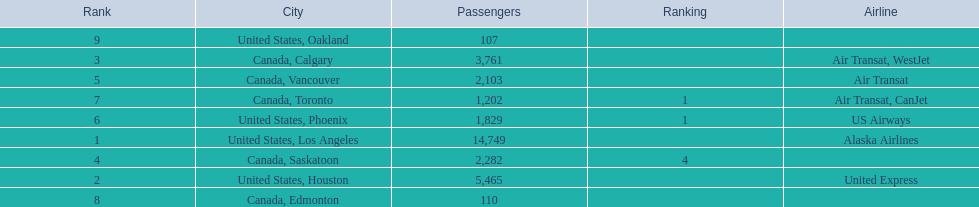What are all the cities? United States, Los Angeles, United States, Houston, Canada, Calgary, Canada, Saskatoon, Canada, Vancouver, United States, Phoenix, Canada, Toronto, Canada, Edmonton, United States, Oakland. How many passengers do they service? 14,749, 5,465, 3,761, 2,282, 2,103, 1,829, 1,202, 110, 107. Which city, when combined with los angeles, totals nearly 19,000? Canada, Calgary. Can you give me this table as a dict? {'header': ['Rank', 'City', 'Passengers', 'Ranking', 'Airline'], 'rows': [['9', 'United States, Oakland', '107', '', ''], ['3', 'Canada, Calgary', '3,761', '', 'Air Transat, WestJet'], ['5', 'Canada, Vancouver', '2,103', '', 'Air Transat'], ['7', 'Canada, Toronto', '1,202', '1', 'Air Transat, CanJet'], ['6', 'United States, Phoenix', '1,829', '1', 'US Airways'], ['1', 'United States, Los Angeles', '14,749', '', 'Alaska Airlines'], ['4', 'Canada, Saskatoon', '2,282', '4', ''], ['2', 'United States, Houston', '5,465', '', 'United Express'], ['8', 'Canada, Edmonton', '110', '', '']]} 